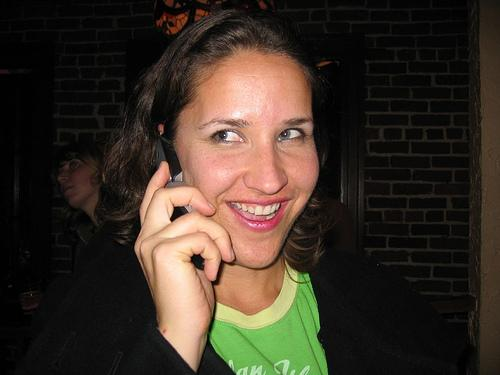Which hand is she using to hold the phone? Please explain your reasoning. right. The woman is using her right hand. 